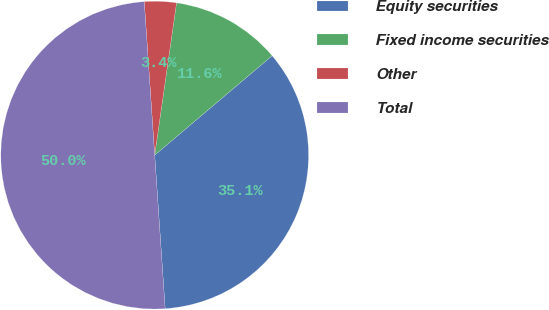Convert chart. <chart><loc_0><loc_0><loc_500><loc_500><pie_chart><fcel>Equity securities<fcel>Fixed income securities<fcel>Other<fcel>Total<nl><fcel>35.1%<fcel>11.55%<fcel>3.35%<fcel>50.0%<nl></chart> 